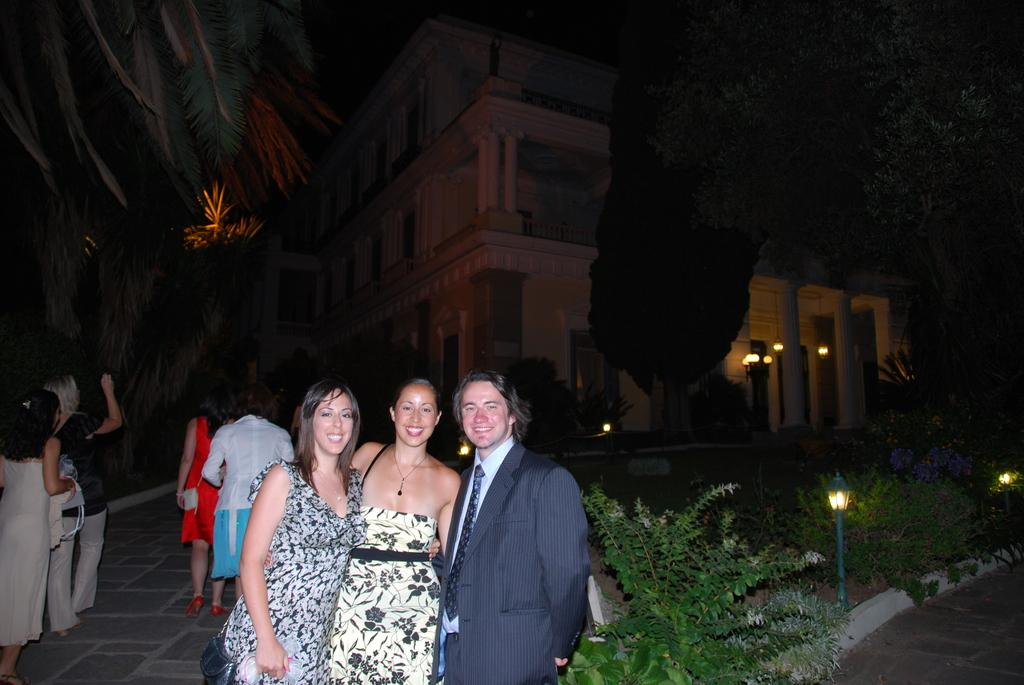How many people are present in the image? There are people in the image, but the exact number is not specified. What are some people wearing in the image? Some people are wearing bags in the image. What type of natural elements can be seen in the image? There are trees and plants in the image. What man-made structures are present in the image? There are poles and a pillar in the image. What type of artificial lighting is visible in the image? There are lights in the image. What type of background can be seen in the image? There is a building in the background of the image. How many yokes are being carried by the people in the image? There is no mention of yokes in the image, so it is not possible to determine how many are being carried. 